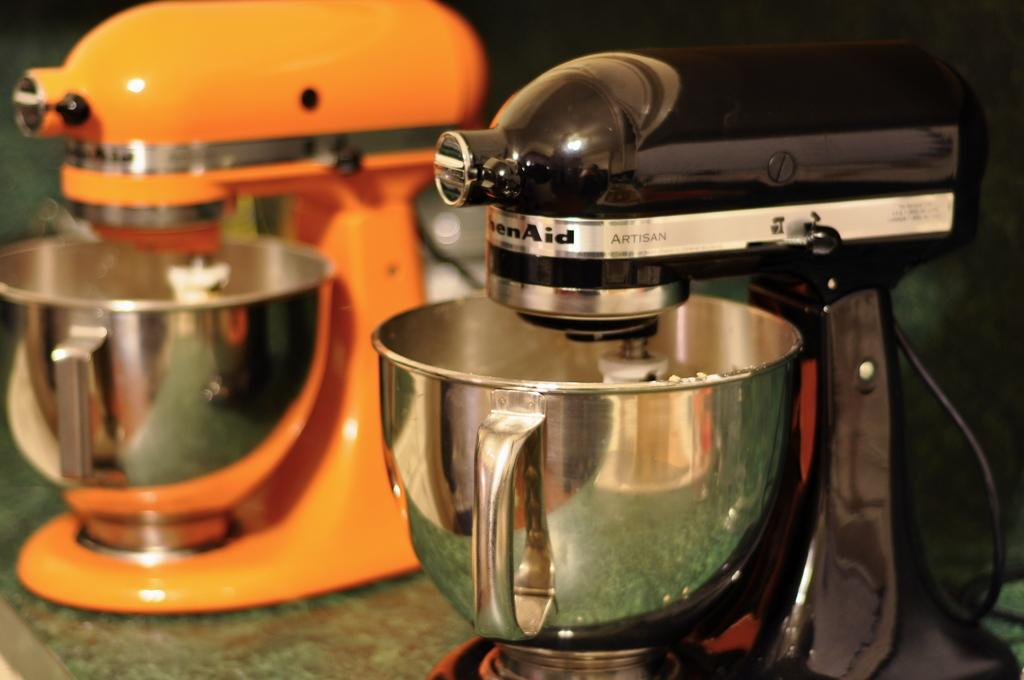<image>
Relay a brief, clear account of the picture shown. On the counter are two KitchenAid brand mixers, an orange one and a black. 